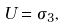Convert formula to latex. <formula><loc_0><loc_0><loc_500><loc_500>U = \sigma _ { 3 } ,</formula> 